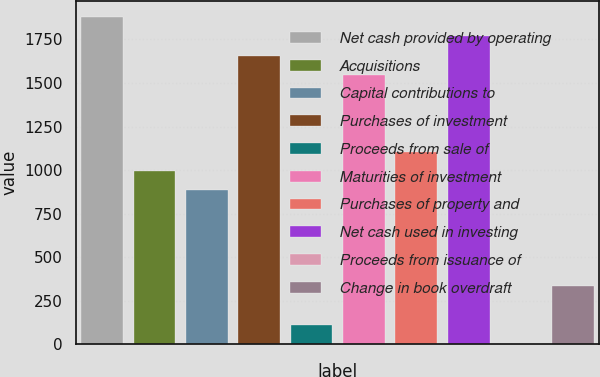<chart> <loc_0><loc_0><loc_500><loc_500><bar_chart><fcel>Net cash provided by operating<fcel>Acquisitions<fcel>Capital contributions to<fcel>Purchases of investment<fcel>Proceeds from sale of<fcel>Maturities of investment<fcel>Purchases of property and<fcel>Net cash used in investing<fcel>Proceeds from issuance of<fcel>Change in book overdraft<nl><fcel>1878.6<fcel>995.64<fcel>885.27<fcel>1657.86<fcel>112.68<fcel>1547.49<fcel>1106.01<fcel>1768.23<fcel>2.31<fcel>333.42<nl></chart> 